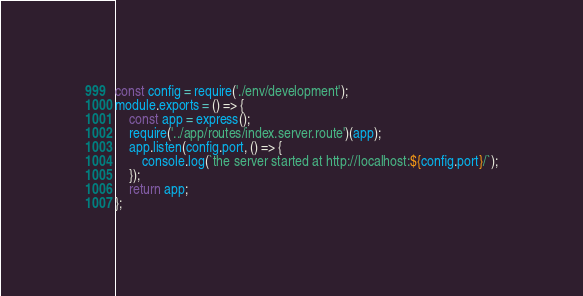<code> <loc_0><loc_0><loc_500><loc_500><_JavaScript_>const config = require('./env/development');
module.exports = () => {
    const app = express();
    require('../app/routes/index.server.route')(app);
    app.listen(config.port, () => {
        console.log(`the server started at http://localhost:${config.port}/`);
    });
    return app;
};</code> 